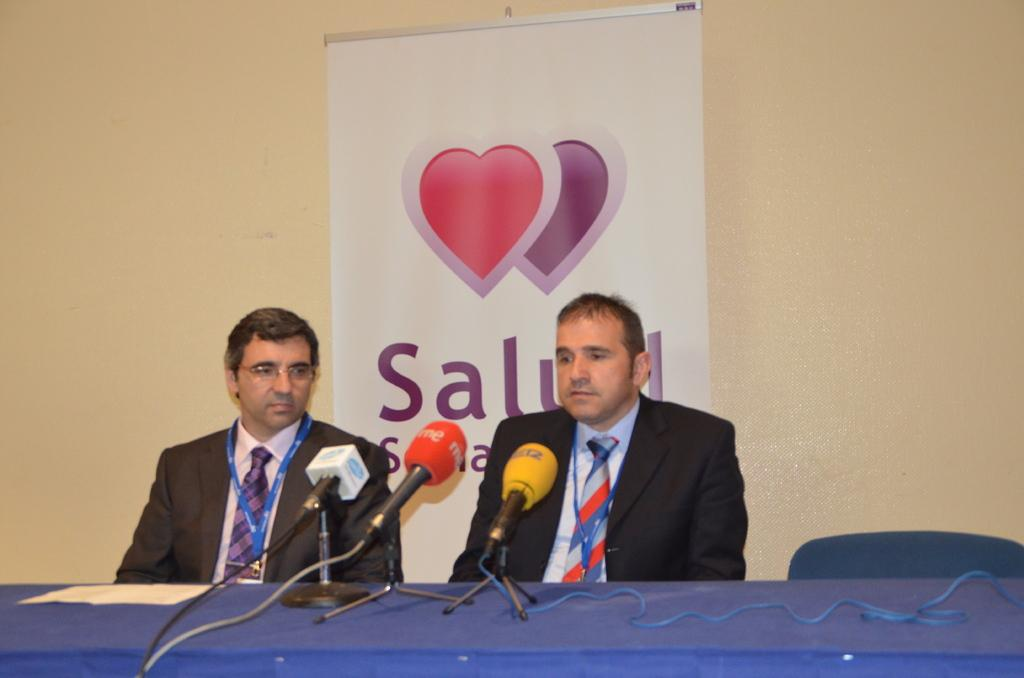How many people are present in the image? There are two persons sitting in the image. What are the persons wearing? The persons are wearing tags. What is located in front of the persons? There is a table in front of the persons. What objects are on the table? There are microphones with stands on the table. What can be seen in the background of the image? There is a wall with a banner in the background. Can you tell me how many gloves are on the table in the image? There are no gloves present on the table in the image. What type of tooth is visible on the banner in the background? There is no tooth depicted on the banner in the background; it features a different design or message. 